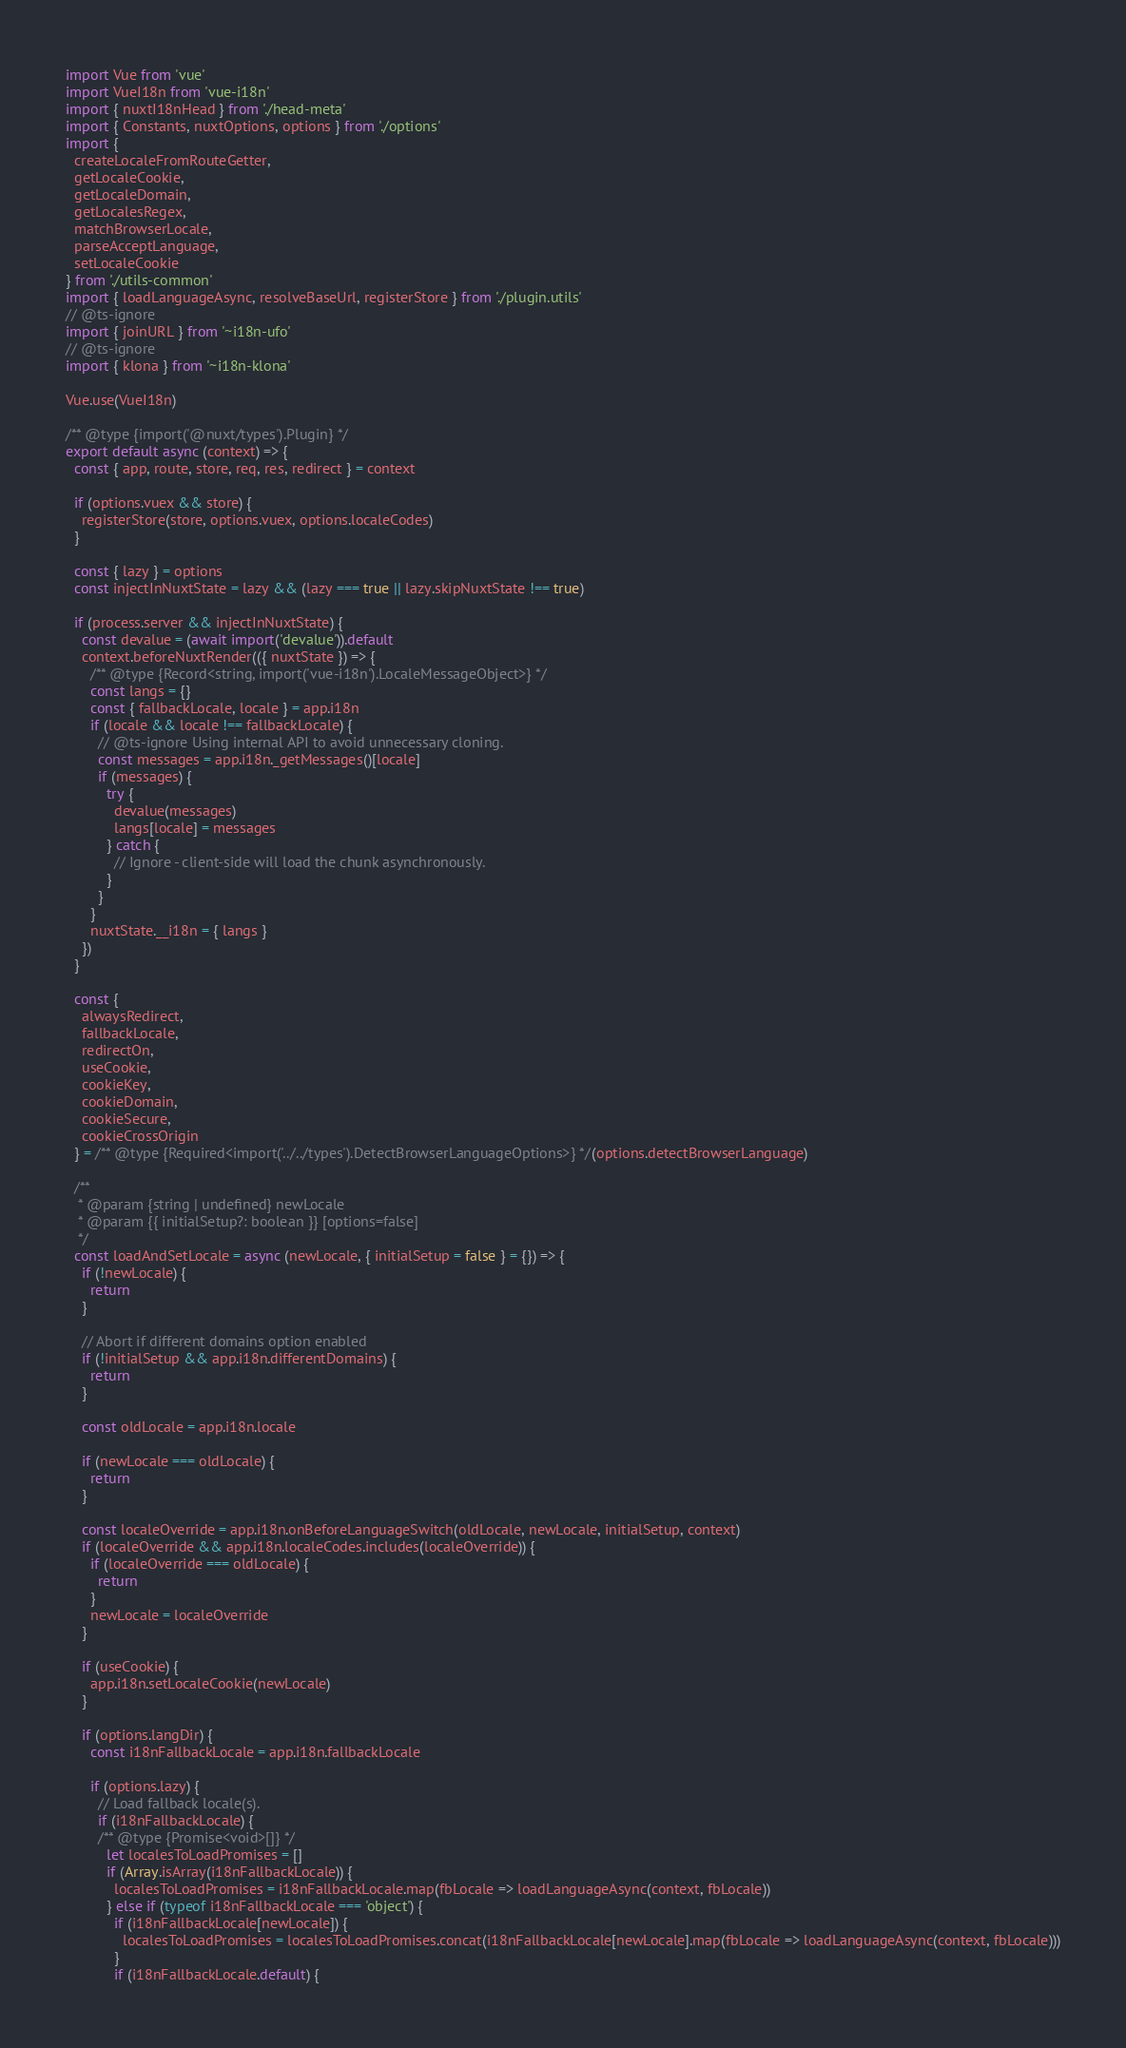<code> <loc_0><loc_0><loc_500><loc_500><_JavaScript_>import Vue from 'vue'
import VueI18n from 'vue-i18n'
import { nuxtI18nHead } from './head-meta'
import { Constants, nuxtOptions, options } from './options'
import {
  createLocaleFromRouteGetter,
  getLocaleCookie,
  getLocaleDomain,
  getLocalesRegex,
  matchBrowserLocale,
  parseAcceptLanguage,
  setLocaleCookie
} from './utils-common'
import { loadLanguageAsync, resolveBaseUrl, registerStore } from './plugin.utils'
// @ts-ignore
import { joinURL } from '~i18n-ufo'
// @ts-ignore
import { klona } from '~i18n-klona'

Vue.use(VueI18n)

/** @type {import('@nuxt/types').Plugin} */
export default async (context) => {
  const { app, route, store, req, res, redirect } = context

  if (options.vuex && store) {
    registerStore(store, options.vuex, options.localeCodes)
  }

  const { lazy } = options
  const injectInNuxtState = lazy && (lazy === true || lazy.skipNuxtState !== true)

  if (process.server && injectInNuxtState) {
    const devalue = (await import('devalue')).default
    context.beforeNuxtRender(({ nuxtState }) => {
      /** @type {Record<string, import('vue-i18n').LocaleMessageObject>} */
      const langs = {}
      const { fallbackLocale, locale } = app.i18n
      if (locale && locale !== fallbackLocale) {
        // @ts-ignore Using internal API to avoid unnecessary cloning.
        const messages = app.i18n._getMessages()[locale]
        if (messages) {
          try {
            devalue(messages)
            langs[locale] = messages
          } catch {
            // Ignore - client-side will load the chunk asynchronously.
          }
        }
      }
      nuxtState.__i18n = { langs }
    })
  }

  const {
    alwaysRedirect,
    fallbackLocale,
    redirectOn,
    useCookie,
    cookieKey,
    cookieDomain,
    cookieSecure,
    cookieCrossOrigin
  } = /** @type {Required<import('../../types').DetectBrowserLanguageOptions>} */(options.detectBrowserLanguage)

  /**
   * @param {string | undefined} newLocale
   * @param {{ initialSetup?: boolean }} [options=false]
   */
  const loadAndSetLocale = async (newLocale, { initialSetup = false } = {}) => {
    if (!newLocale) {
      return
    }

    // Abort if different domains option enabled
    if (!initialSetup && app.i18n.differentDomains) {
      return
    }

    const oldLocale = app.i18n.locale

    if (newLocale === oldLocale) {
      return
    }

    const localeOverride = app.i18n.onBeforeLanguageSwitch(oldLocale, newLocale, initialSetup, context)
    if (localeOverride && app.i18n.localeCodes.includes(localeOverride)) {
      if (localeOverride === oldLocale) {
        return
      }
      newLocale = localeOverride
    }

    if (useCookie) {
      app.i18n.setLocaleCookie(newLocale)
    }

    if (options.langDir) {
      const i18nFallbackLocale = app.i18n.fallbackLocale

      if (options.lazy) {
        // Load fallback locale(s).
        if (i18nFallbackLocale) {
        /** @type {Promise<void>[]} */
          let localesToLoadPromises = []
          if (Array.isArray(i18nFallbackLocale)) {
            localesToLoadPromises = i18nFallbackLocale.map(fbLocale => loadLanguageAsync(context, fbLocale))
          } else if (typeof i18nFallbackLocale === 'object') {
            if (i18nFallbackLocale[newLocale]) {
              localesToLoadPromises = localesToLoadPromises.concat(i18nFallbackLocale[newLocale].map(fbLocale => loadLanguageAsync(context, fbLocale)))
            }
            if (i18nFallbackLocale.default) {</code> 